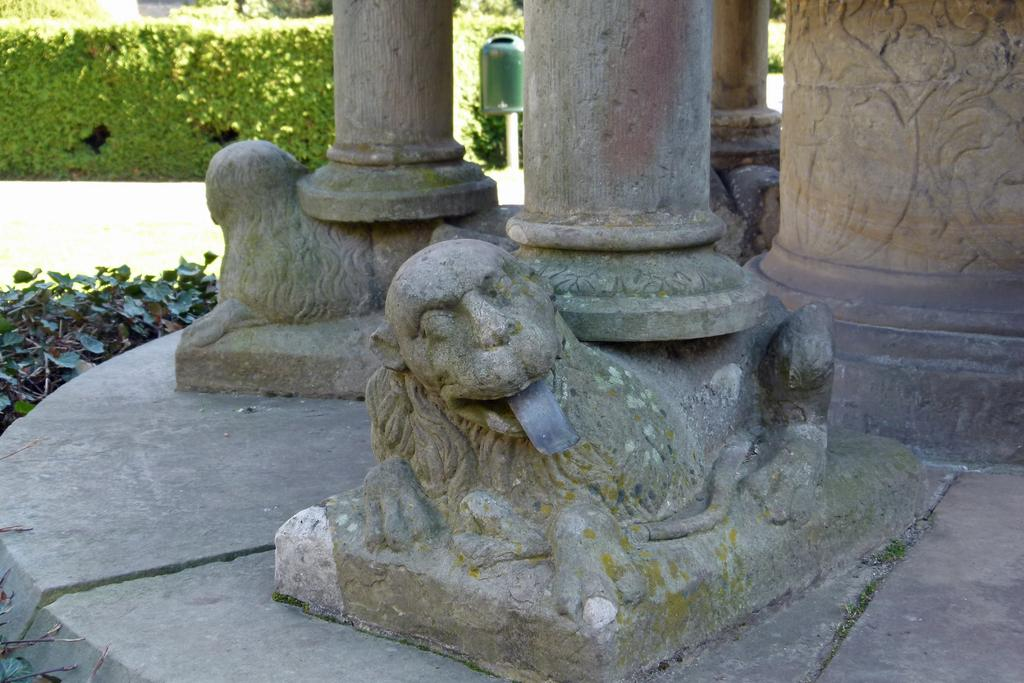What objects can be seen in the image that are vertical in nature? There are poles in the image. What animals are depicted in the image? There is a depiction of lions in the image. What type of natural environment is visible in the background of the image? There are trees in the background of the image. What additional detail can be observed on the path in the background? Leaves are present on the path in the background of the image. What type of screw can be seen in the image? There is no screw present in the image. How does the image depict the concept of death? The image does not depict the concept of death; it features poles, lions, trees, and leaves on a path. 